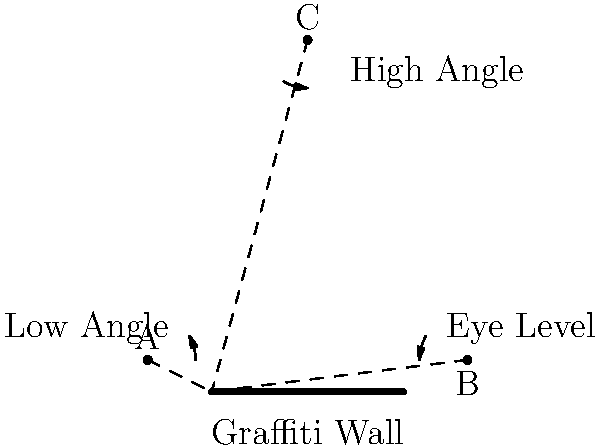In the diagram, three camera positions (A, B, and C) are shown for capturing graffiti art on a wall. Which camera position would be most effective for emphasizing the scale and depth of the graffiti piece, and why? To determine the most effective camera position for emphasizing scale and depth of the graffiti piece, let's analyze each position:

1. Position A (Low Angle):
   - Creates a sense of power and dominance
   - Exaggerates the height of the graffiti
   - Can distort proportions

2. Position B (Eye Level):
   - Provides a natural, realistic view
   - Maintains accurate proportions
   - Lacks dramatic effect

3. Position C (High Angle):
   - Offers an overview of the entire piece
   - Emphasizes the scale of the artwork
   - Creates depth by showing the relationship between the graffiti and its surroundings

Position C (High Angle) is the most effective for emphasizing scale and depth because:
1. It provides a broader view of the entire graffiti piece, allowing viewers to appreciate its full scale.
2. The elevated perspective creates a sense of depth by showing the graffiti in relation to its environment.
3. This angle can capture the texture of the wall and the dimensionality of the artwork more effectively.
4. It allows for the inclusion of foreground elements, further enhancing the perception of depth.

While positions A and B have their merits, they don't offer the same combination of scale and depth perception that position C provides.
Answer: Position C (High Angle) 